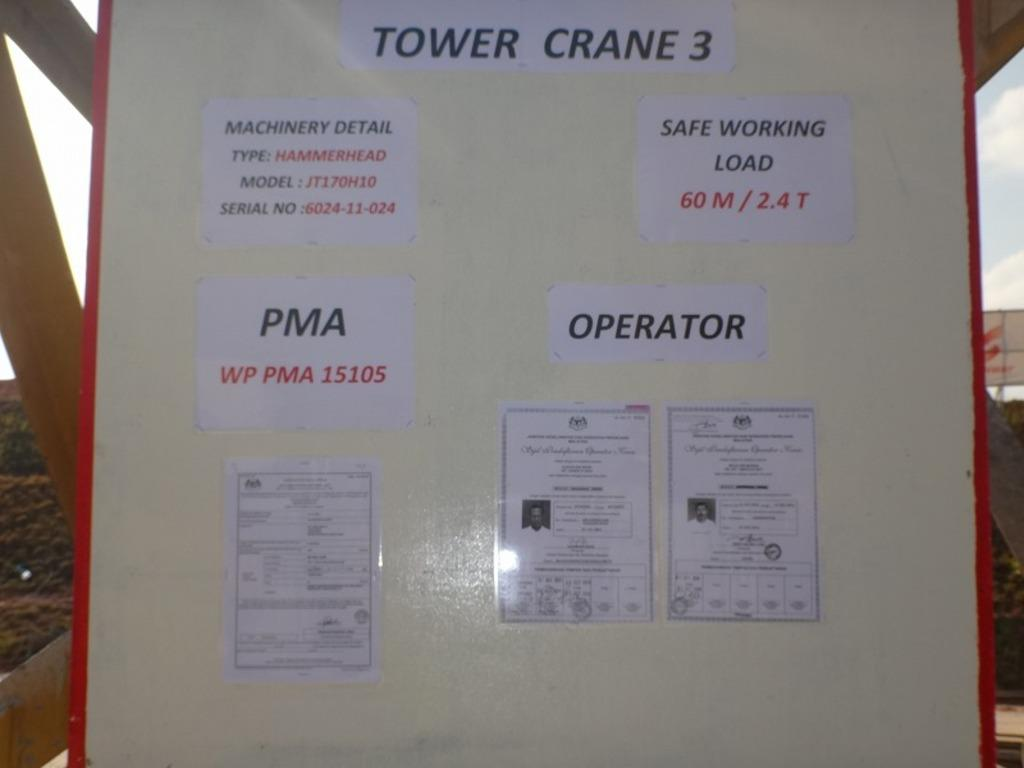<image>
Share a concise interpretation of the image provided. A sign board with many papers taped to it for a Tower crane 